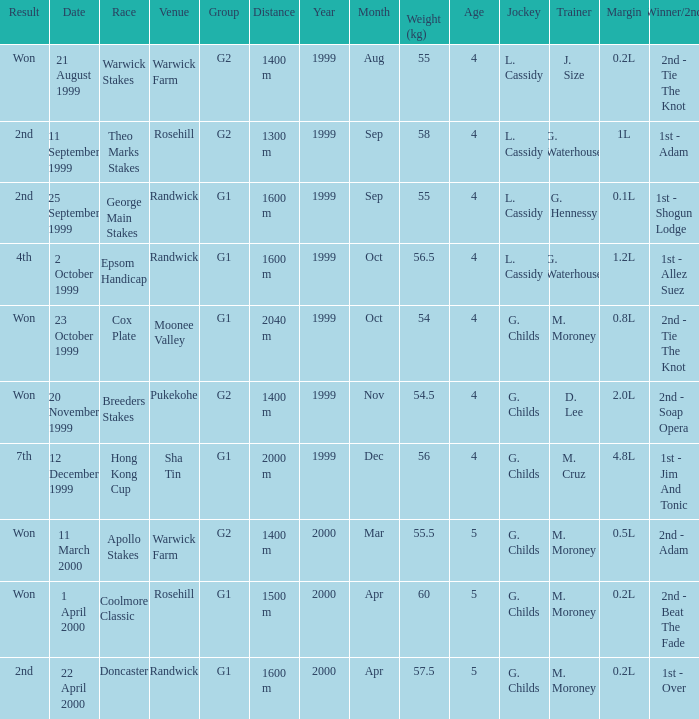List the weight for 56.5 kilograms. Epsom Handicap. 